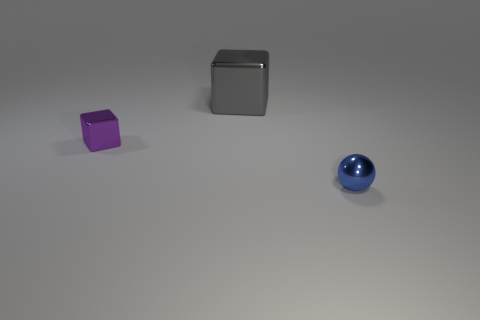Add 2 large red shiny things. How many objects exist? 5 Subtract all spheres. How many objects are left? 2 Subtract all large brown metal spheres. Subtract all purple objects. How many objects are left? 2 Add 1 metal blocks. How many metal blocks are left? 3 Add 2 balls. How many balls exist? 3 Subtract 0 green spheres. How many objects are left? 3 